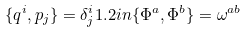<formula> <loc_0><loc_0><loc_500><loc_500>\{ q ^ { i } , p _ { j } \} = \delta _ { j } ^ { i } 1 . 2 i n \{ \Phi ^ { a } , \Phi ^ { b } \} = \omega ^ { a b }</formula> 